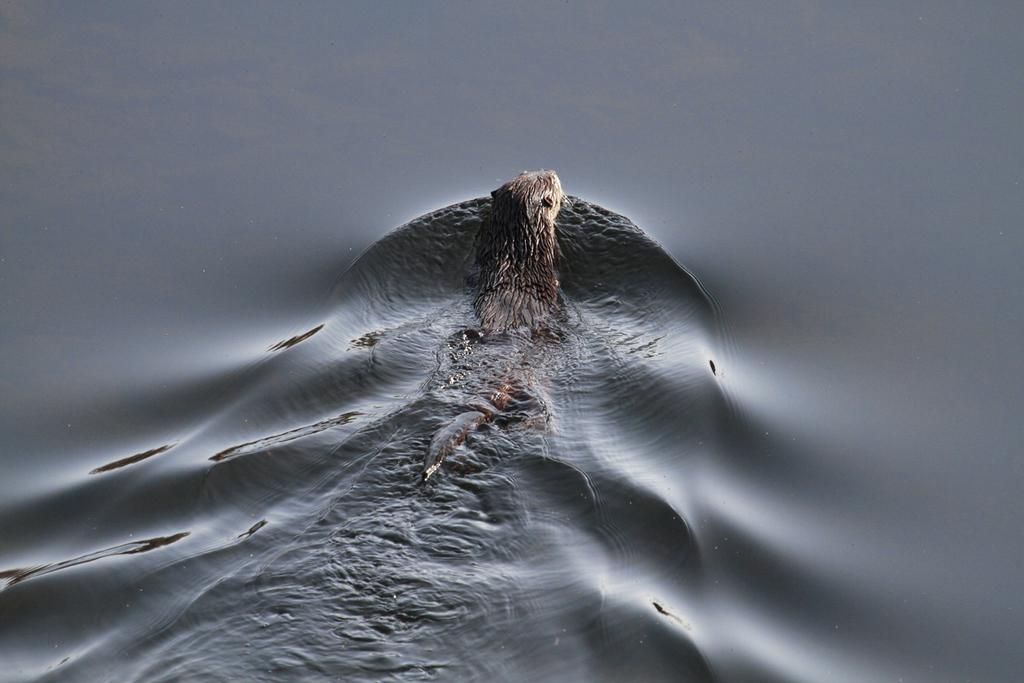What type of animal is in the image? The facts provided do not specify the type of animal in the image. Where is the animal located in the image? The animal is inside the water. What type of plough is being used by the animal in the image? There is no plough present in the image, as the animal is inside the water. Can you tell me the total cost of the receipt in the image? There is no receipt present in the image. 